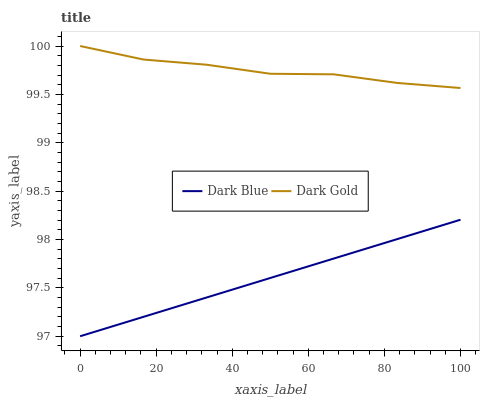Does Dark Gold have the minimum area under the curve?
Answer yes or no. No. Is Dark Gold the smoothest?
Answer yes or no. No. Does Dark Gold have the lowest value?
Answer yes or no. No. Is Dark Blue less than Dark Gold?
Answer yes or no. Yes. Is Dark Gold greater than Dark Blue?
Answer yes or no. Yes. Does Dark Blue intersect Dark Gold?
Answer yes or no. No. 